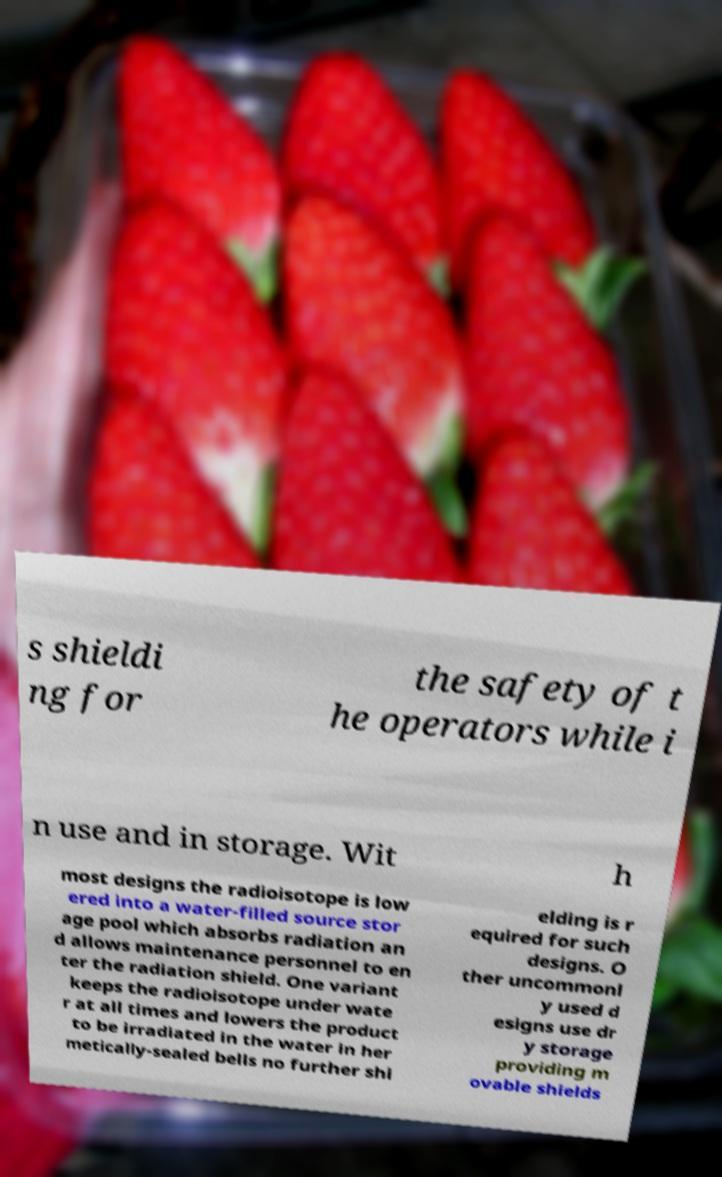Please read and relay the text visible in this image. What does it say? s shieldi ng for the safety of t he operators while i n use and in storage. Wit h most designs the radioisotope is low ered into a water-filled source stor age pool which absorbs radiation an d allows maintenance personnel to en ter the radiation shield. One variant keeps the radioisotope under wate r at all times and lowers the product to be irradiated in the water in her metically-sealed bells no further shi elding is r equired for such designs. O ther uncommonl y used d esigns use dr y storage providing m ovable shields 